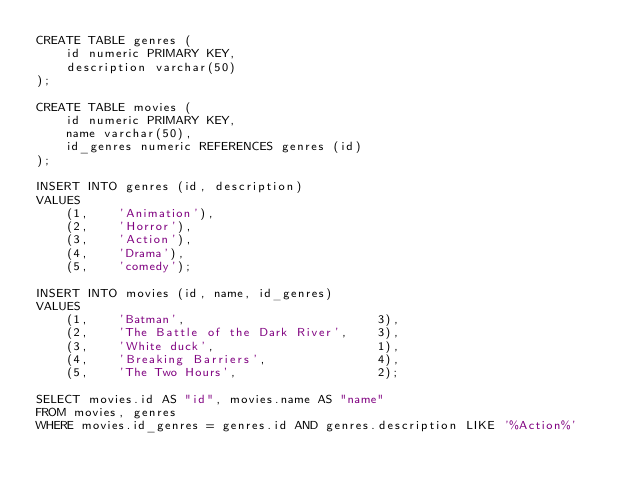<code> <loc_0><loc_0><loc_500><loc_500><_SQL_>CREATE TABLE genres (
    id numeric PRIMARY KEY,
    description varchar(50)
);

CREATE TABLE movies (
    id numeric PRIMARY KEY,
    name varchar(50),
    id_genres numeric REFERENCES genres (id)
);

INSERT INTO genres (id, description)
VALUES
    (1,    'Animation'),
    (2,    'Horror'),
    (3,    'Action'),
    (4,    'Drama'),
    (5,    'comedy');

INSERT INTO movies (id, name, id_genres)
VALUES
    (1,    'Batman',                          3),
    (2,    'The Battle of the Dark River',    3),
    (3,    'White duck',                      1),
    (4,    'Breaking Barriers',               4),
    (5,    'The Two Hours',                   2);

SELECT movies.id AS "id", movies.name AS "name"
FROM movies, genres
WHERE movies.id_genres = genres.id AND genres.description LIKE '%Action%'</code> 